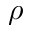<formula> <loc_0><loc_0><loc_500><loc_500>\rho</formula> 